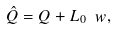Convert formula to latex. <formula><loc_0><loc_0><loc_500><loc_500>\hat { Q } = Q + L _ { 0 } \ w ,</formula> 